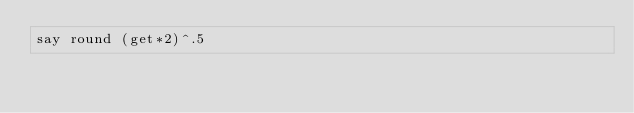<code> <loc_0><loc_0><loc_500><loc_500><_Perl_>say round (get*2)^.5</code> 